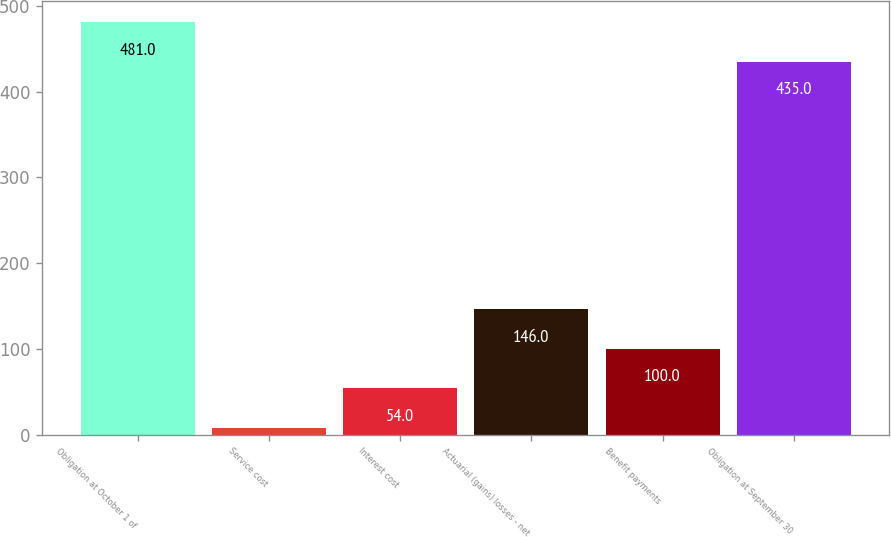<chart> <loc_0><loc_0><loc_500><loc_500><bar_chart><fcel>Obligation at October 1 of<fcel>Service cost<fcel>Interest cost<fcel>Actuarial (gains) losses - net<fcel>Benefit payments<fcel>Obligation at September 30<nl><fcel>481<fcel>8<fcel>54<fcel>146<fcel>100<fcel>435<nl></chart> 